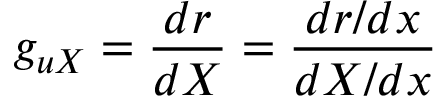<formula> <loc_0><loc_0><loc_500><loc_500>g _ { u X } = \frac { d r } { d X } = \frac { d r / d x } { d X / d x }</formula> 